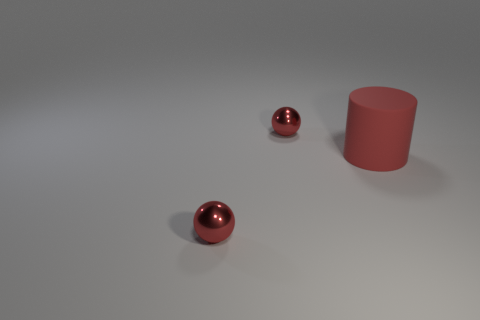How many shiny spheres are behind the small red thing left of the metallic sphere behind the big matte thing? There is one shiny sphere positioned behind the small red cylinder, which is to the left of the metallic sphere and also behind the larger matte object. 